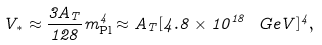Convert formula to latex. <formula><loc_0><loc_0><loc_500><loc_500>V _ { * } \approx \frac { 3 A _ { T } } { 1 2 8 } m _ { \text {Pl} } ^ { 4 } \approx A _ { T } [ 4 . 8 \times 1 0 ^ { 1 8 } \ G e V ] ^ { 4 } ,</formula> 